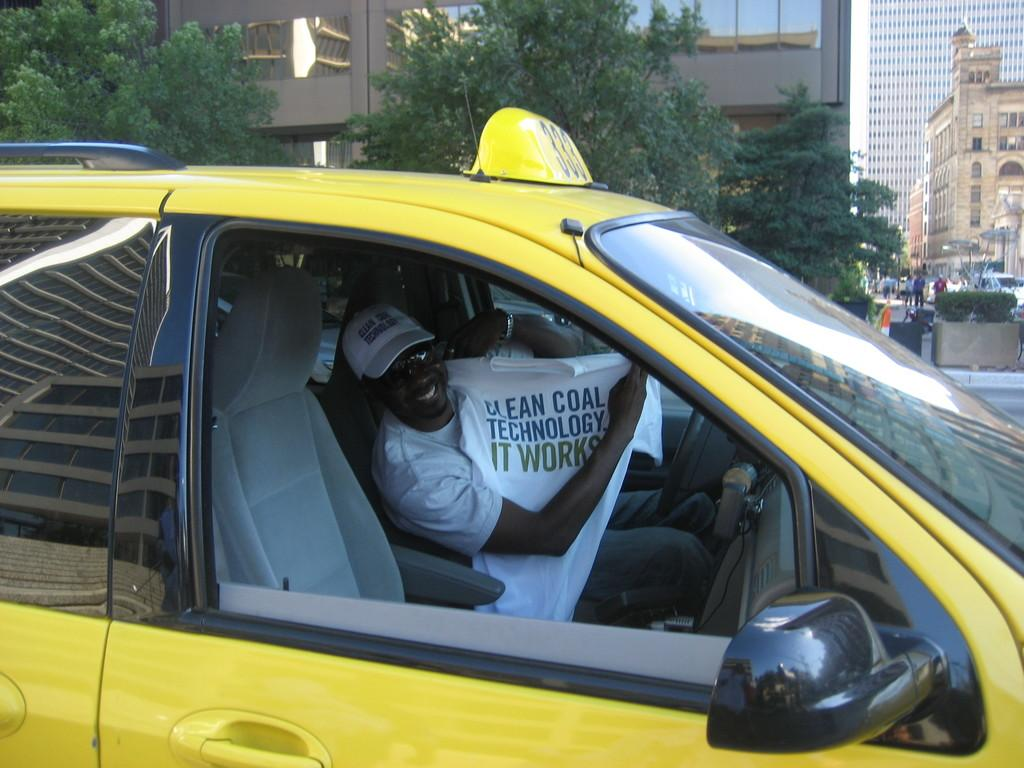<image>
Provide a brief description of the given image. A man in a taxi is holding a shirt that says "Clean Coal Technology. It Works." 